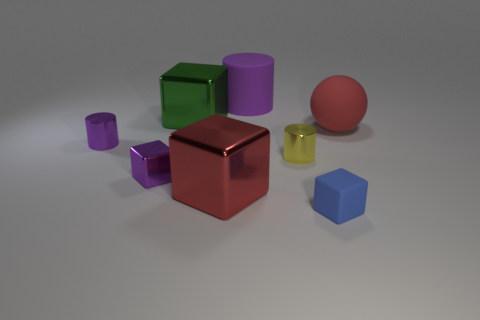Subtract all green spheres. How many purple cylinders are left? 2 Subtract all big purple cylinders. How many cylinders are left? 2 Subtract all green cubes. How many cubes are left? 3 Subtract 1 cylinders. How many cylinders are left? 2 Add 1 red metallic things. How many objects exist? 9 Subtract all yellow blocks. Subtract all blue balls. How many blocks are left? 4 Subtract all balls. How many objects are left? 7 Add 8 red matte spheres. How many red matte spheres are left? 9 Add 5 small balls. How many small balls exist? 5 Subtract 0 gray cylinders. How many objects are left? 8 